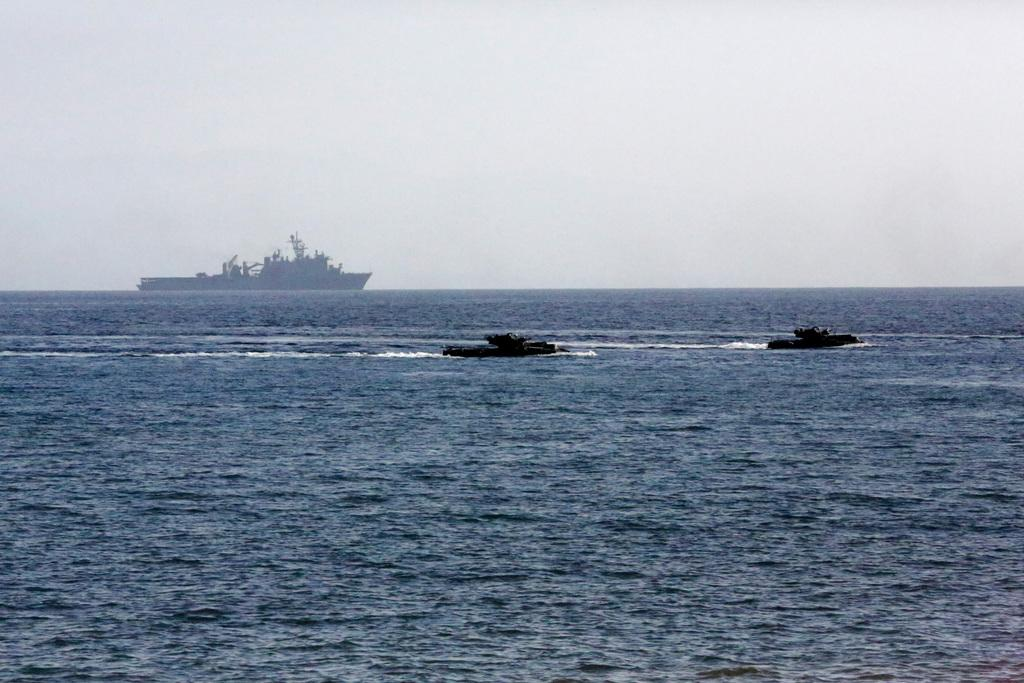What is the main subject of the image? The main subject of the image is boats. Where are the boats located? The boats are on the water. What is the color of the water in the image? The water is blue in color. What can be seen in the background of the image? The sky is visible in the background of the image. How many sisters are depicted in the image? There are no sisters present in the image; it features boats on the water. What level of experience is required to operate the boats in the image? The image does not provide information about the level of experience required to operate the boats, nor does it depict any people operating them. 